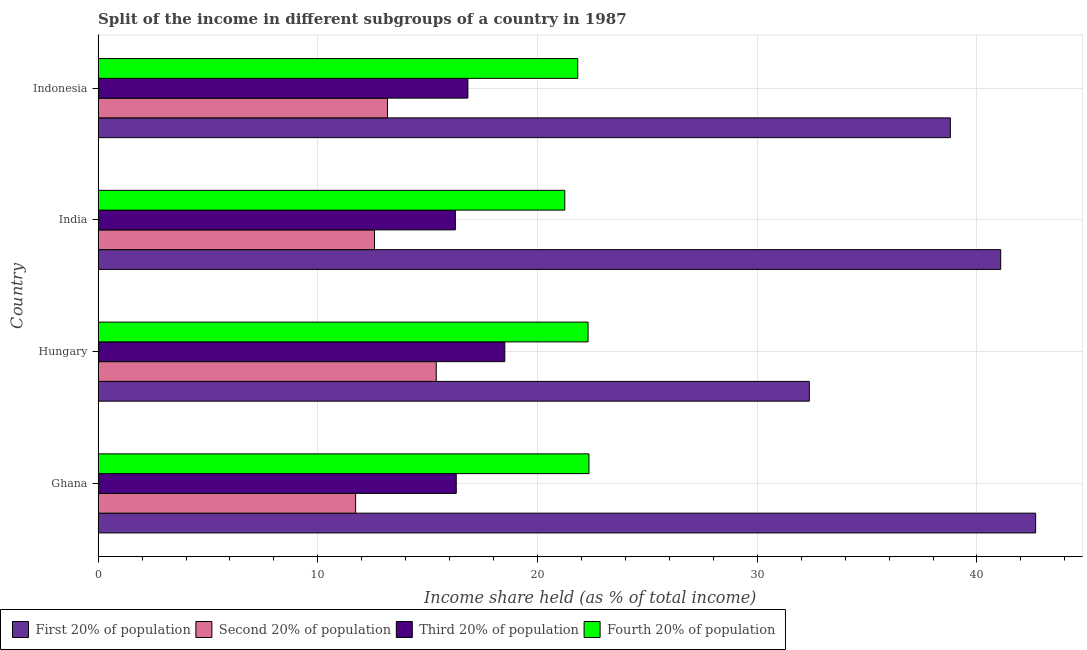How many different coloured bars are there?
Give a very brief answer. 4. Are the number of bars on each tick of the Y-axis equal?
Your answer should be very brief. Yes. How many bars are there on the 3rd tick from the top?
Ensure brevity in your answer.  4. What is the label of the 1st group of bars from the top?
Offer a terse response. Indonesia. In how many cases, is the number of bars for a given country not equal to the number of legend labels?
Offer a very short reply. 0. What is the share of the income held by fourth 20% of the population in India?
Give a very brief answer. 21.24. Across all countries, what is the maximum share of the income held by third 20% of the population?
Provide a short and direct response. 18.51. Across all countries, what is the minimum share of the income held by fourth 20% of the population?
Provide a succinct answer. 21.24. In which country was the share of the income held by second 20% of the population maximum?
Your answer should be very brief. Hungary. In which country was the share of the income held by second 20% of the population minimum?
Your answer should be compact. Ghana. What is the total share of the income held by fourth 20% of the population in the graph?
Give a very brief answer. 87.71. What is the difference between the share of the income held by first 20% of the population in Hungary and that in India?
Your answer should be compact. -8.71. What is the difference between the share of the income held by second 20% of the population in Indonesia and the share of the income held by fourth 20% of the population in India?
Give a very brief answer. -8.07. What is the average share of the income held by fourth 20% of the population per country?
Offer a terse response. 21.93. What is the difference between the share of the income held by first 20% of the population and share of the income held by second 20% of the population in Ghana?
Keep it short and to the point. 30.95. What is the ratio of the share of the income held by first 20% of the population in Hungary to that in India?
Offer a terse response. 0.79. Is the share of the income held by fourth 20% of the population in Ghana less than that in Hungary?
Your answer should be very brief. No. Is the difference between the share of the income held by third 20% of the population in Hungary and India greater than the difference between the share of the income held by fourth 20% of the population in Hungary and India?
Keep it short and to the point. Yes. What is the difference between the highest and the second highest share of the income held by first 20% of the population?
Your answer should be very brief. 1.59. What is the difference between the highest and the lowest share of the income held by third 20% of the population?
Your response must be concise. 2.25. Is the sum of the share of the income held by fourth 20% of the population in Ghana and Hungary greater than the maximum share of the income held by third 20% of the population across all countries?
Offer a terse response. Yes. What does the 1st bar from the top in India represents?
Give a very brief answer. Fourth 20% of population. What does the 3rd bar from the bottom in Hungary represents?
Your answer should be compact. Third 20% of population. Are all the bars in the graph horizontal?
Ensure brevity in your answer.  Yes. How many countries are there in the graph?
Offer a very short reply. 4. What is the difference between two consecutive major ticks on the X-axis?
Offer a very short reply. 10. Where does the legend appear in the graph?
Provide a succinct answer. Bottom left. How many legend labels are there?
Your answer should be very brief. 4. How are the legend labels stacked?
Offer a terse response. Horizontal. What is the title of the graph?
Your answer should be compact. Split of the income in different subgroups of a country in 1987. Does "Building human resources" appear as one of the legend labels in the graph?
Your answer should be very brief. No. What is the label or title of the X-axis?
Ensure brevity in your answer.  Income share held (as % of total income). What is the label or title of the Y-axis?
Give a very brief answer. Country. What is the Income share held (as % of total income) of First 20% of population in Ghana?
Your response must be concise. 42.67. What is the Income share held (as % of total income) in Second 20% of population in Ghana?
Ensure brevity in your answer.  11.72. What is the Income share held (as % of total income) of Third 20% of population in Ghana?
Offer a terse response. 16.3. What is the Income share held (as % of total income) of Fourth 20% of population in Ghana?
Ensure brevity in your answer.  22.34. What is the Income share held (as % of total income) of First 20% of population in Hungary?
Your answer should be very brief. 32.37. What is the Income share held (as % of total income) of Second 20% of population in Hungary?
Offer a terse response. 15.39. What is the Income share held (as % of total income) in Third 20% of population in Hungary?
Offer a terse response. 18.51. What is the Income share held (as % of total income) in Fourth 20% of population in Hungary?
Your answer should be very brief. 22.3. What is the Income share held (as % of total income) of First 20% of population in India?
Your answer should be very brief. 41.08. What is the Income share held (as % of total income) of Second 20% of population in India?
Your response must be concise. 12.58. What is the Income share held (as % of total income) of Third 20% of population in India?
Make the answer very short. 16.26. What is the Income share held (as % of total income) of Fourth 20% of population in India?
Your answer should be very brief. 21.24. What is the Income share held (as % of total income) of First 20% of population in Indonesia?
Offer a terse response. 38.79. What is the Income share held (as % of total income) in Second 20% of population in Indonesia?
Provide a succinct answer. 13.17. What is the Income share held (as % of total income) in Third 20% of population in Indonesia?
Your answer should be compact. 16.83. What is the Income share held (as % of total income) in Fourth 20% of population in Indonesia?
Keep it short and to the point. 21.83. Across all countries, what is the maximum Income share held (as % of total income) of First 20% of population?
Ensure brevity in your answer.  42.67. Across all countries, what is the maximum Income share held (as % of total income) in Second 20% of population?
Make the answer very short. 15.39. Across all countries, what is the maximum Income share held (as % of total income) in Third 20% of population?
Give a very brief answer. 18.51. Across all countries, what is the maximum Income share held (as % of total income) in Fourth 20% of population?
Your response must be concise. 22.34. Across all countries, what is the minimum Income share held (as % of total income) of First 20% of population?
Offer a terse response. 32.37. Across all countries, what is the minimum Income share held (as % of total income) in Second 20% of population?
Provide a succinct answer. 11.72. Across all countries, what is the minimum Income share held (as % of total income) in Third 20% of population?
Ensure brevity in your answer.  16.26. Across all countries, what is the minimum Income share held (as % of total income) in Fourth 20% of population?
Offer a terse response. 21.24. What is the total Income share held (as % of total income) of First 20% of population in the graph?
Ensure brevity in your answer.  154.91. What is the total Income share held (as % of total income) in Second 20% of population in the graph?
Provide a succinct answer. 52.86. What is the total Income share held (as % of total income) of Third 20% of population in the graph?
Provide a short and direct response. 67.9. What is the total Income share held (as % of total income) of Fourth 20% of population in the graph?
Give a very brief answer. 87.71. What is the difference between the Income share held (as % of total income) of First 20% of population in Ghana and that in Hungary?
Keep it short and to the point. 10.3. What is the difference between the Income share held (as % of total income) of Second 20% of population in Ghana and that in Hungary?
Give a very brief answer. -3.67. What is the difference between the Income share held (as % of total income) of Third 20% of population in Ghana and that in Hungary?
Provide a short and direct response. -2.21. What is the difference between the Income share held (as % of total income) in First 20% of population in Ghana and that in India?
Offer a very short reply. 1.59. What is the difference between the Income share held (as % of total income) of Second 20% of population in Ghana and that in India?
Keep it short and to the point. -0.86. What is the difference between the Income share held (as % of total income) of Fourth 20% of population in Ghana and that in India?
Ensure brevity in your answer.  1.1. What is the difference between the Income share held (as % of total income) in First 20% of population in Ghana and that in Indonesia?
Your response must be concise. 3.88. What is the difference between the Income share held (as % of total income) of Second 20% of population in Ghana and that in Indonesia?
Make the answer very short. -1.45. What is the difference between the Income share held (as % of total income) in Third 20% of population in Ghana and that in Indonesia?
Your answer should be compact. -0.53. What is the difference between the Income share held (as % of total income) of Fourth 20% of population in Ghana and that in Indonesia?
Your response must be concise. 0.51. What is the difference between the Income share held (as % of total income) in First 20% of population in Hungary and that in India?
Provide a succinct answer. -8.71. What is the difference between the Income share held (as % of total income) in Second 20% of population in Hungary and that in India?
Make the answer very short. 2.81. What is the difference between the Income share held (as % of total income) in Third 20% of population in Hungary and that in India?
Your answer should be compact. 2.25. What is the difference between the Income share held (as % of total income) of Fourth 20% of population in Hungary and that in India?
Ensure brevity in your answer.  1.06. What is the difference between the Income share held (as % of total income) of First 20% of population in Hungary and that in Indonesia?
Your answer should be very brief. -6.42. What is the difference between the Income share held (as % of total income) of Second 20% of population in Hungary and that in Indonesia?
Keep it short and to the point. 2.22. What is the difference between the Income share held (as % of total income) in Third 20% of population in Hungary and that in Indonesia?
Offer a terse response. 1.68. What is the difference between the Income share held (as % of total income) in Fourth 20% of population in Hungary and that in Indonesia?
Give a very brief answer. 0.47. What is the difference between the Income share held (as % of total income) in First 20% of population in India and that in Indonesia?
Keep it short and to the point. 2.29. What is the difference between the Income share held (as % of total income) in Second 20% of population in India and that in Indonesia?
Your response must be concise. -0.59. What is the difference between the Income share held (as % of total income) of Third 20% of population in India and that in Indonesia?
Your answer should be compact. -0.57. What is the difference between the Income share held (as % of total income) of Fourth 20% of population in India and that in Indonesia?
Offer a very short reply. -0.59. What is the difference between the Income share held (as % of total income) of First 20% of population in Ghana and the Income share held (as % of total income) of Second 20% of population in Hungary?
Give a very brief answer. 27.28. What is the difference between the Income share held (as % of total income) of First 20% of population in Ghana and the Income share held (as % of total income) of Third 20% of population in Hungary?
Give a very brief answer. 24.16. What is the difference between the Income share held (as % of total income) of First 20% of population in Ghana and the Income share held (as % of total income) of Fourth 20% of population in Hungary?
Ensure brevity in your answer.  20.37. What is the difference between the Income share held (as % of total income) of Second 20% of population in Ghana and the Income share held (as % of total income) of Third 20% of population in Hungary?
Give a very brief answer. -6.79. What is the difference between the Income share held (as % of total income) of Second 20% of population in Ghana and the Income share held (as % of total income) of Fourth 20% of population in Hungary?
Your answer should be compact. -10.58. What is the difference between the Income share held (as % of total income) in Third 20% of population in Ghana and the Income share held (as % of total income) in Fourth 20% of population in Hungary?
Your response must be concise. -6. What is the difference between the Income share held (as % of total income) in First 20% of population in Ghana and the Income share held (as % of total income) in Second 20% of population in India?
Make the answer very short. 30.09. What is the difference between the Income share held (as % of total income) in First 20% of population in Ghana and the Income share held (as % of total income) in Third 20% of population in India?
Offer a very short reply. 26.41. What is the difference between the Income share held (as % of total income) in First 20% of population in Ghana and the Income share held (as % of total income) in Fourth 20% of population in India?
Your answer should be compact. 21.43. What is the difference between the Income share held (as % of total income) of Second 20% of population in Ghana and the Income share held (as % of total income) of Third 20% of population in India?
Give a very brief answer. -4.54. What is the difference between the Income share held (as % of total income) of Second 20% of population in Ghana and the Income share held (as % of total income) of Fourth 20% of population in India?
Keep it short and to the point. -9.52. What is the difference between the Income share held (as % of total income) in Third 20% of population in Ghana and the Income share held (as % of total income) in Fourth 20% of population in India?
Ensure brevity in your answer.  -4.94. What is the difference between the Income share held (as % of total income) of First 20% of population in Ghana and the Income share held (as % of total income) of Second 20% of population in Indonesia?
Make the answer very short. 29.5. What is the difference between the Income share held (as % of total income) of First 20% of population in Ghana and the Income share held (as % of total income) of Third 20% of population in Indonesia?
Provide a succinct answer. 25.84. What is the difference between the Income share held (as % of total income) of First 20% of population in Ghana and the Income share held (as % of total income) of Fourth 20% of population in Indonesia?
Your response must be concise. 20.84. What is the difference between the Income share held (as % of total income) of Second 20% of population in Ghana and the Income share held (as % of total income) of Third 20% of population in Indonesia?
Your answer should be compact. -5.11. What is the difference between the Income share held (as % of total income) in Second 20% of population in Ghana and the Income share held (as % of total income) in Fourth 20% of population in Indonesia?
Offer a very short reply. -10.11. What is the difference between the Income share held (as % of total income) of Third 20% of population in Ghana and the Income share held (as % of total income) of Fourth 20% of population in Indonesia?
Provide a succinct answer. -5.53. What is the difference between the Income share held (as % of total income) of First 20% of population in Hungary and the Income share held (as % of total income) of Second 20% of population in India?
Ensure brevity in your answer.  19.79. What is the difference between the Income share held (as % of total income) in First 20% of population in Hungary and the Income share held (as % of total income) in Third 20% of population in India?
Provide a short and direct response. 16.11. What is the difference between the Income share held (as % of total income) of First 20% of population in Hungary and the Income share held (as % of total income) of Fourth 20% of population in India?
Your response must be concise. 11.13. What is the difference between the Income share held (as % of total income) in Second 20% of population in Hungary and the Income share held (as % of total income) in Third 20% of population in India?
Keep it short and to the point. -0.87. What is the difference between the Income share held (as % of total income) in Second 20% of population in Hungary and the Income share held (as % of total income) in Fourth 20% of population in India?
Provide a succinct answer. -5.85. What is the difference between the Income share held (as % of total income) in Third 20% of population in Hungary and the Income share held (as % of total income) in Fourth 20% of population in India?
Provide a short and direct response. -2.73. What is the difference between the Income share held (as % of total income) of First 20% of population in Hungary and the Income share held (as % of total income) of Second 20% of population in Indonesia?
Provide a short and direct response. 19.2. What is the difference between the Income share held (as % of total income) in First 20% of population in Hungary and the Income share held (as % of total income) in Third 20% of population in Indonesia?
Provide a succinct answer. 15.54. What is the difference between the Income share held (as % of total income) in First 20% of population in Hungary and the Income share held (as % of total income) in Fourth 20% of population in Indonesia?
Provide a short and direct response. 10.54. What is the difference between the Income share held (as % of total income) of Second 20% of population in Hungary and the Income share held (as % of total income) of Third 20% of population in Indonesia?
Your answer should be very brief. -1.44. What is the difference between the Income share held (as % of total income) in Second 20% of population in Hungary and the Income share held (as % of total income) in Fourth 20% of population in Indonesia?
Offer a very short reply. -6.44. What is the difference between the Income share held (as % of total income) of Third 20% of population in Hungary and the Income share held (as % of total income) of Fourth 20% of population in Indonesia?
Make the answer very short. -3.32. What is the difference between the Income share held (as % of total income) of First 20% of population in India and the Income share held (as % of total income) of Second 20% of population in Indonesia?
Your answer should be compact. 27.91. What is the difference between the Income share held (as % of total income) in First 20% of population in India and the Income share held (as % of total income) in Third 20% of population in Indonesia?
Keep it short and to the point. 24.25. What is the difference between the Income share held (as % of total income) in First 20% of population in India and the Income share held (as % of total income) in Fourth 20% of population in Indonesia?
Keep it short and to the point. 19.25. What is the difference between the Income share held (as % of total income) in Second 20% of population in India and the Income share held (as % of total income) in Third 20% of population in Indonesia?
Make the answer very short. -4.25. What is the difference between the Income share held (as % of total income) in Second 20% of population in India and the Income share held (as % of total income) in Fourth 20% of population in Indonesia?
Your response must be concise. -9.25. What is the difference between the Income share held (as % of total income) in Third 20% of population in India and the Income share held (as % of total income) in Fourth 20% of population in Indonesia?
Provide a succinct answer. -5.57. What is the average Income share held (as % of total income) of First 20% of population per country?
Provide a short and direct response. 38.73. What is the average Income share held (as % of total income) of Second 20% of population per country?
Your answer should be compact. 13.21. What is the average Income share held (as % of total income) of Third 20% of population per country?
Provide a short and direct response. 16.98. What is the average Income share held (as % of total income) in Fourth 20% of population per country?
Ensure brevity in your answer.  21.93. What is the difference between the Income share held (as % of total income) of First 20% of population and Income share held (as % of total income) of Second 20% of population in Ghana?
Offer a terse response. 30.95. What is the difference between the Income share held (as % of total income) of First 20% of population and Income share held (as % of total income) of Third 20% of population in Ghana?
Ensure brevity in your answer.  26.37. What is the difference between the Income share held (as % of total income) of First 20% of population and Income share held (as % of total income) of Fourth 20% of population in Ghana?
Keep it short and to the point. 20.33. What is the difference between the Income share held (as % of total income) of Second 20% of population and Income share held (as % of total income) of Third 20% of population in Ghana?
Make the answer very short. -4.58. What is the difference between the Income share held (as % of total income) of Second 20% of population and Income share held (as % of total income) of Fourth 20% of population in Ghana?
Keep it short and to the point. -10.62. What is the difference between the Income share held (as % of total income) of Third 20% of population and Income share held (as % of total income) of Fourth 20% of population in Ghana?
Your answer should be compact. -6.04. What is the difference between the Income share held (as % of total income) of First 20% of population and Income share held (as % of total income) of Second 20% of population in Hungary?
Provide a short and direct response. 16.98. What is the difference between the Income share held (as % of total income) in First 20% of population and Income share held (as % of total income) in Third 20% of population in Hungary?
Your response must be concise. 13.86. What is the difference between the Income share held (as % of total income) in First 20% of population and Income share held (as % of total income) in Fourth 20% of population in Hungary?
Your answer should be compact. 10.07. What is the difference between the Income share held (as % of total income) in Second 20% of population and Income share held (as % of total income) in Third 20% of population in Hungary?
Your answer should be compact. -3.12. What is the difference between the Income share held (as % of total income) in Second 20% of population and Income share held (as % of total income) in Fourth 20% of population in Hungary?
Offer a very short reply. -6.91. What is the difference between the Income share held (as % of total income) in Third 20% of population and Income share held (as % of total income) in Fourth 20% of population in Hungary?
Offer a very short reply. -3.79. What is the difference between the Income share held (as % of total income) of First 20% of population and Income share held (as % of total income) of Second 20% of population in India?
Make the answer very short. 28.5. What is the difference between the Income share held (as % of total income) in First 20% of population and Income share held (as % of total income) in Third 20% of population in India?
Make the answer very short. 24.82. What is the difference between the Income share held (as % of total income) of First 20% of population and Income share held (as % of total income) of Fourth 20% of population in India?
Your answer should be very brief. 19.84. What is the difference between the Income share held (as % of total income) in Second 20% of population and Income share held (as % of total income) in Third 20% of population in India?
Offer a terse response. -3.68. What is the difference between the Income share held (as % of total income) in Second 20% of population and Income share held (as % of total income) in Fourth 20% of population in India?
Provide a succinct answer. -8.66. What is the difference between the Income share held (as % of total income) in Third 20% of population and Income share held (as % of total income) in Fourth 20% of population in India?
Offer a very short reply. -4.98. What is the difference between the Income share held (as % of total income) of First 20% of population and Income share held (as % of total income) of Second 20% of population in Indonesia?
Offer a very short reply. 25.62. What is the difference between the Income share held (as % of total income) in First 20% of population and Income share held (as % of total income) in Third 20% of population in Indonesia?
Your answer should be very brief. 21.96. What is the difference between the Income share held (as % of total income) of First 20% of population and Income share held (as % of total income) of Fourth 20% of population in Indonesia?
Your answer should be compact. 16.96. What is the difference between the Income share held (as % of total income) in Second 20% of population and Income share held (as % of total income) in Third 20% of population in Indonesia?
Ensure brevity in your answer.  -3.66. What is the difference between the Income share held (as % of total income) in Second 20% of population and Income share held (as % of total income) in Fourth 20% of population in Indonesia?
Offer a very short reply. -8.66. What is the difference between the Income share held (as % of total income) of Third 20% of population and Income share held (as % of total income) of Fourth 20% of population in Indonesia?
Your answer should be very brief. -5. What is the ratio of the Income share held (as % of total income) in First 20% of population in Ghana to that in Hungary?
Give a very brief answer. 1.32. What is the ratio of the Income share held (as % of total income) of Second 20% of population in Ghana to that in Hungary?
Your response must be concise. 0.76. What is the ratio of the Income share held (as % of total income) of Third 20% of population in Ghana to that in Hungary?
Keep it short and to the point. 0.88. What is the ratio of the Income share held (as % of total income) of Fourth 20% of population in Ghana to that in Hungary?
Ensure brevity in your answer.  1. What is the ratio of the Income share held (as % of total income) of First 20% of population in Ghana to that in India?
Ensure brevity in your answer.  1.04. What is the ratio of the Income share held (as % of total income) in Second 20% of population in Ghana to that in India?
Make the answer very short. 0.93. What is the ratio of the Income share held (as % of total income) in Fourth 20% of population in Ghana to that in India?
Provide a short and direct response. 1.05. What is the ratio of the Income share held (as % of total income) in First 20% of population in Ghana to that in Indonesia?
Your answer should be compact. 1.1. What is the ratio of the Income share held (as % of total income) of Second 20% of population in Ghana to that in Indonesia?
Your answer should be very brief. 0.89. What is the ratio of the Income share held (as % of total income) of Third 20% of population in Ghana to that in Indonesia?
Make the answer very short. 0.97. What is the ratio of the Income share held (as % of total income) of Fourth 20% of population in Ghana to that in Indonesia?
Provide a short and direct response. 1.02. What is the ratio of the Income share held (as % of total income) in First 20% of population in Hungary to that in India?
Your answer should be very brief. 0.79. What is the ratio of the Income share held (as % of total income) of Second 20% of population in Hungary to that in India?
Offer a terse response. 1.22. What is the ratio of the Income share held (as % of total income) in Third 20% of population in Hungary to that in India?
Make the answer very short. 1.14. What is the ratio of the Income share held (as % of total income) in Fourth 20% of population in Hungary to that in India?
Your answer should be compact. 1.05. What is the ratio of the Income share held (as % of total income) of First 20% of population in Hungary to that in Indonesia?
Provide a succinct answer. 0.83. What is the ratio of the Income share held (as % of total income) in Second 20% of population in Hungary to that in Indonesia?
Your response must be concise. 1.17. What is the ratio of the Income share held (as % of total income) of Third 20% of population in Hungary to that in Indonesia?
Make the answer very short. 1.1. What is the ratio of the Income share held (as % of total income) in Fourth 20% of population in Hungary to that in Indonesia?
Offer a terse response. 1.02. What is the ratio of the Income share held (as % of total income) in First 20% of population in India to that in Indonesia?
Your response must be concise. 1.06. What is the ratio of the Income share held (as % of total income) of Second 20% of population in India to that in Indonesia?
Your response must be concise. 0.96. What is the ratio of the Income share held (as % of total income) of Third 20% of population in India to that in Indonesia?
Keep it short and to the point. 0.97. What is the difference between the highest and the second highest Income share held (as % of total income) of First 20% of population?
Your response must be concise. 1.59. What is the difference between the highest and the second highest Income share held (as % of total income) of Second 20% of population?
Make the answer very short. 2.22. What is the difference between the highest and the second highest Income share held (as % of total income) of Third 20% of population?
Your response must be concise. 1.68. What is the difference between the highest and the second highest Income share held (as % of total income) in Fourth 20% of population?
Make the answer very short. 0.04. What is the difference between the highest and the lowest Income share held (as % of total income) in Second 20% of population?
Offer a terse response. 3.67. What is the difference between the highest and the lowest Income share held (as % of total income) of Third 20% of population?
Your response must be concise. 2.25. 